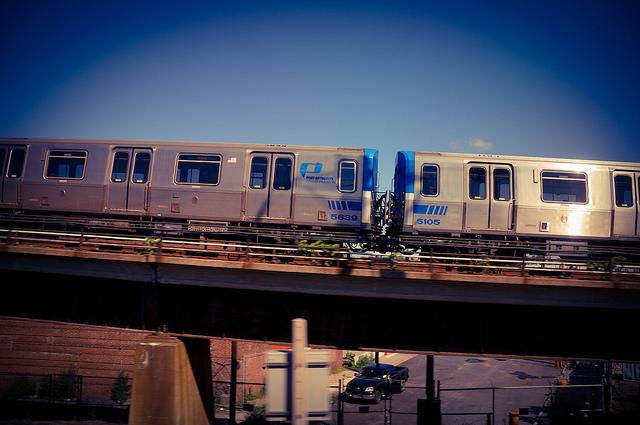What is the main color of the train?
Answer briefly. Silver. Is this on the beach?
Concise answer only. No. Is there a car under the bridge?
Give a very brief answer. Yes. What color is the train?
Concise answer only. Silver. What type of train is this?
Be succinct. Passenger. 